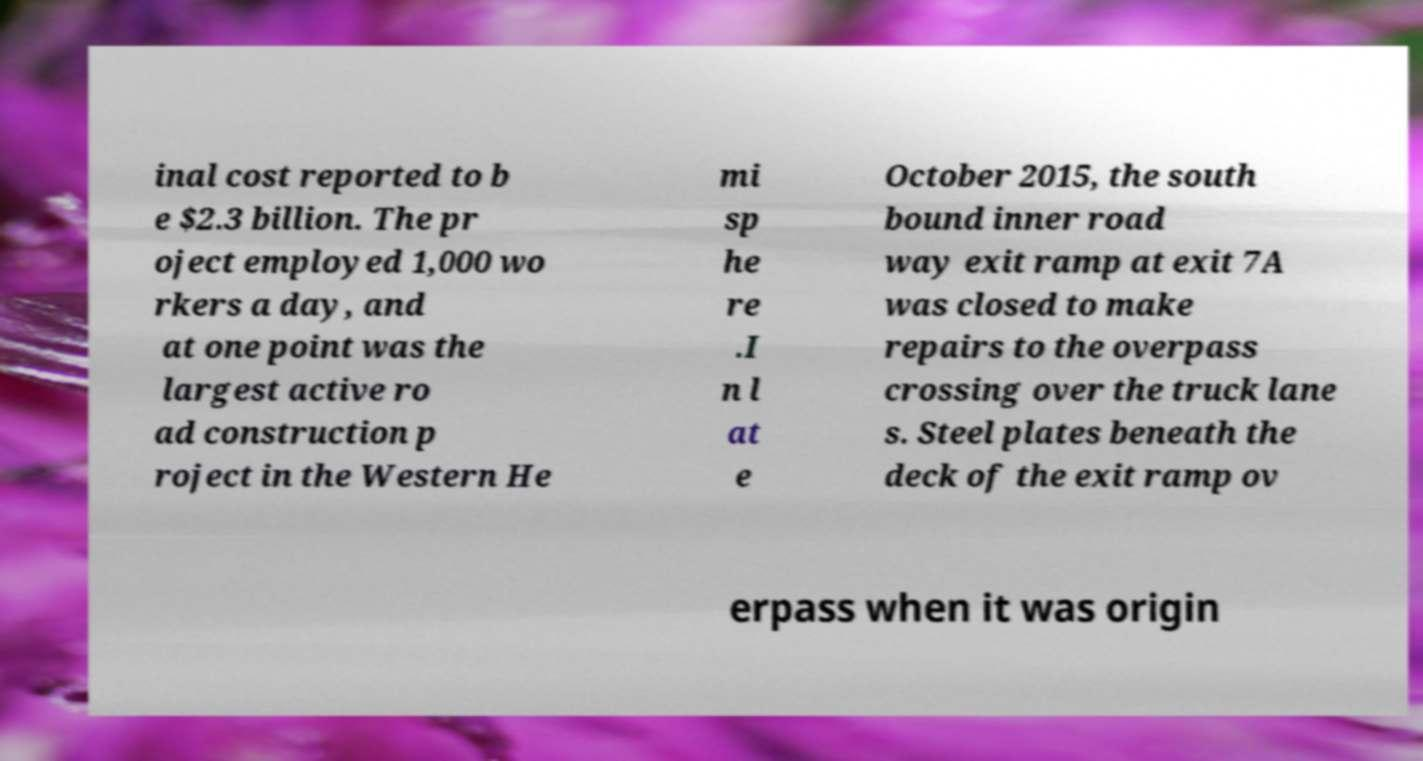What messages or text are displayed in this image? I need them in a readable, typed format. inal cost reported to b e $2.3 billion. The pr oject employed 1,000 wo rkers a day, and at one point was the largest active ro ad construction p roject in the Western He mi sp he re .I n l at e October 2015, the south bound inner road way exit ramp at exit 7A was closed to make repairs to the overpass crossing over the truck lane s. Steel plates beneath the deck of the exit ramp ov erpass when it was origin 